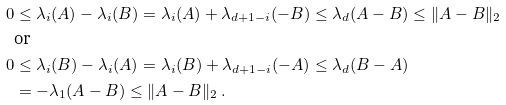Convert formula to latex. <formula><loc_0><loc_0><loc_500><loc_500>0 & \leq \lambda _ { i } ( A ) - \lambda _ { i } ( B ) = \lambda _ { i } ( A ) + \lambda _ { d + 1 - i } ( - B ) \leq \lambda _ { d } ( A - B ) \leq \| A - B \| _ { 2 } \\ & \text {or} \\ 0 & \leq \lambda _ { i } ( B ) - \lambda _ { i } ( A ) = \lambda _ { i } ( B ) + \lambda _ { d + 1 - i } ( - A ) \leq \lambda _ { d } ( B - A ) \\ & = - \lambda _ { 1 } ( A - B ) \leq \| A - B \| _ { 2 } \ .</formula> 